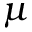<formula> <loc_0><loc_0><loc_500><loc_500>\mu</formula> 